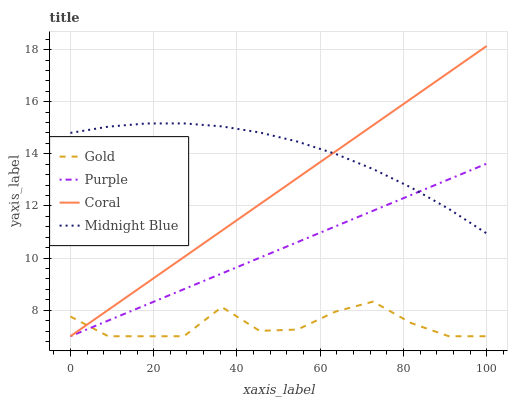Does Gold have the minimum area under the curve?
Answer yes or no. Yes. Does Midnight Blue have the maximum area under the curve?
Answer yes or no. Yes. Does Coral have the minimum area under the curve?
Answer yes or no. No. Does Coral have the maximum area under the curve?
Answer yes or no. No. Is Coral the smoothest?
Answer yes or no. Yes. Is Gold the roughest?
Answer yes or no. Yes. Is Midnight Blue the smoothest?
Answer yes or no. No. Is Midnight Blue the roughest?
Answer yes or no. No. Does Purple have the lowest value?
Answer yes or no. Yes. Does Midnight Blue have the lowest value?
Answer yes or no. No. Does Coral have the highest value?
Answer yes or no. Yes. Does Midnight Blue have the highest value?
Answer yes or no. No. Is Gold less than Midnight Blue?
Answer yes or no. Yes. Is Midnight Blue greater than Gold?
Answer yes or no. Yes. Does Coral intersect Purple?
Answer yes or no. Yes. Is Coral less than Purple?
Answer yes or no. No. Is Coral greater than Purple?
Answer yes or no. No. Does Gold intersect Midnight Blue?
Answer yes or no. No. 